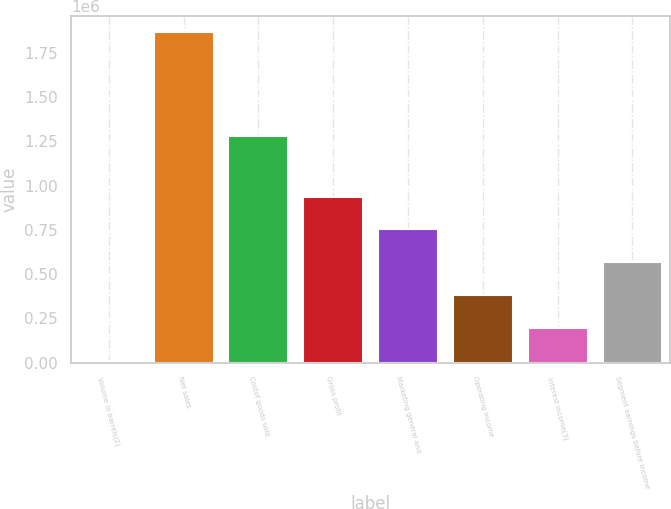Convert chart. <chart><loc_0><loc_0><loc_500><loc_500><bar_chart><fcel>Volume in barrels(2)<fcel>Net sales<fcel>Costof goods sold<fcel>Gross profit<fcel>Marketing general and<fcel>Operating income<fcel>Interest income(3)<fcel>Segment earnings before income<nl><fcel>10635<fcel>1.86493e+06<fcel>1.27932e+06<fcel>937782<fcel>752353<fcel>381494<fcel>196064<fcel>566924<nl></chart> 